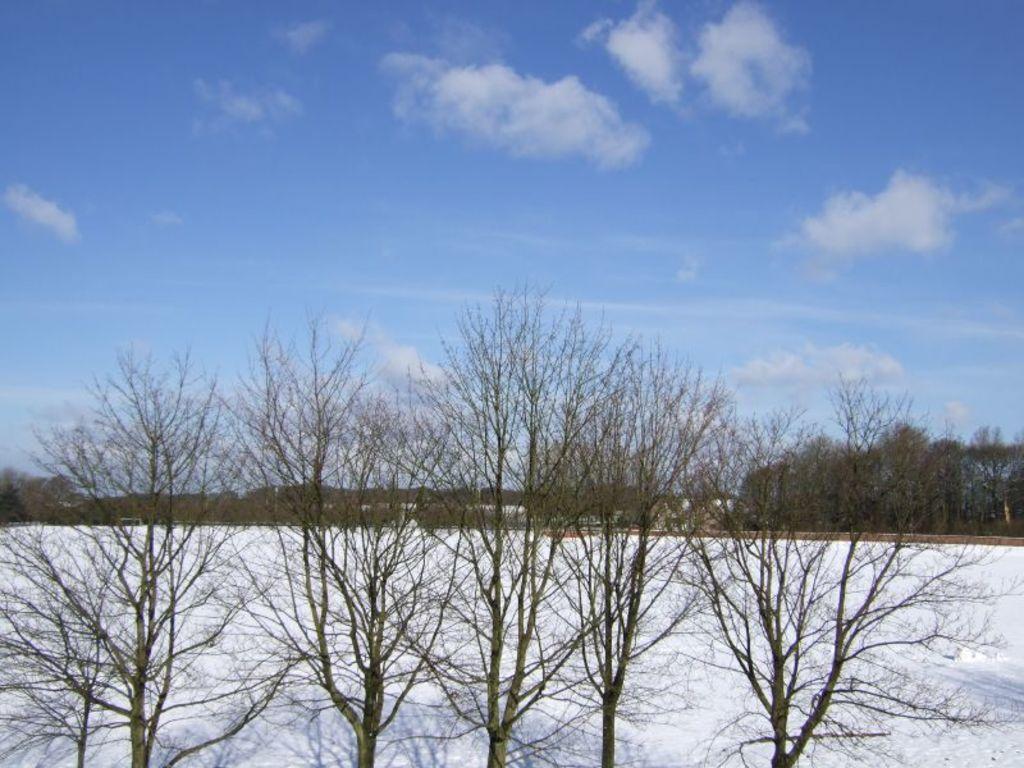Can you describe this image briefly? In this image in the foreground there are some trees, and at the bottom there is snow and in the background there are some trees. And at the top there is sky. 